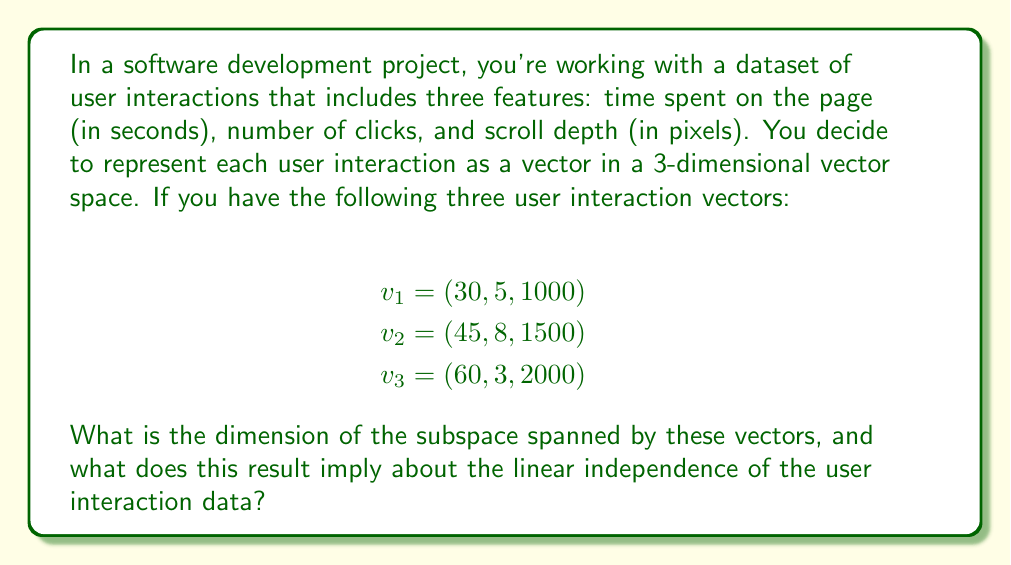Give your solution to this math problem. To solve this problem, we need to determine the dimension of the subspace spanned by the given vectors. This can be done by checking the linear independence of the vectors.

Step 1: Set up the matrix A using the given vectors as columns:

$$A = \begin{bmatrix}
30 & 45 & 60 \\
5 & 8 & 3 \\
1000 & 1500 & 2000
\end{bmatrix}$$

Step 2: Calculate the rank of matrix A. The rank is equal to the number of linearly independent columns (or rows) in the matrix. We can do this by performing Gaussian elimination to obtain the row echelon form:

$$\begin{bmatrix}
30 & 45 & 60 \\
5 & 8 & 3 \\
1000 & 1500 & 2000
\end{bmatrix} \sim
\begin{bmatrix}
30 & 45 & 60 \\
0 & 0.5 & -7 \\
0 & 0 & 0
\end{bmatrix}$$

Step 3: Count the number of non-zero rows in the row echelon form. In this case, there are 2 non-zero rows, so the rank of the matrix is 2.

Step 4: The dimension of the subspace spanned by the vectors is equal to the rank of the matrix. Therefore, the dimension is 2.

Interpretation: The dimension being 2 implies that the three vectors are not linearly independent. Only two of the vectors are linearly independent, and the third can be expressed as a linear combination of the other two. In the context of the user interaction data, this suggests that there is some correlation or redundancy in the data, and the user interactions can be fully described using only two dimensions instead of three.
Answer: The dimension of the subspace spanned by the vectors is 2. This implies that the user interaction data vectors are not linearly independent, and the data can be represented in a 2-dimensional subspace of the original 3-dimensional space. 